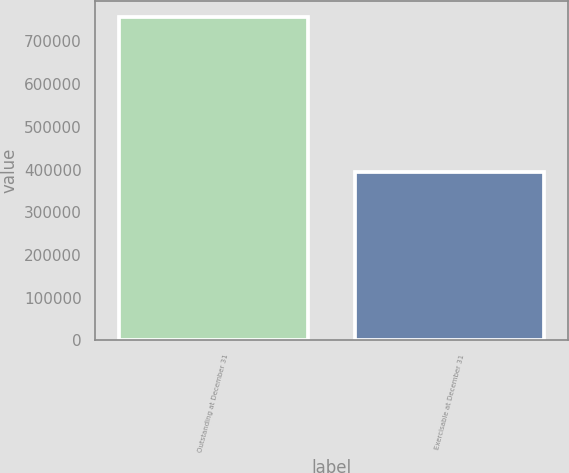<chart> <loc_0><loc_0><loc_500><loc_500><bar_chart><fcel>Outstanding at December 31<fcel>Exercisable at December 31<nl><fcel>757424<fcel>394565<nl></chart> 